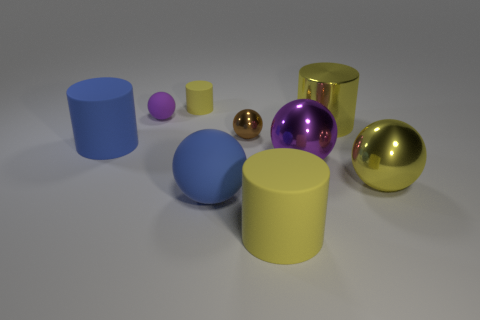How does the lighting in the image affect the appearance of the objects? The lighting plays a significant role in this image. It appears to be diffused and coming from above, creating soft shadows on the floor beneath each object. The metallic objects reflect the light brightly and show highlights and defined reflections, enhancing their glossy texture. In contrast, the matte objects absorb more light, resulting in softer and less pronounced highlights, which emphasizes their texture and form. 